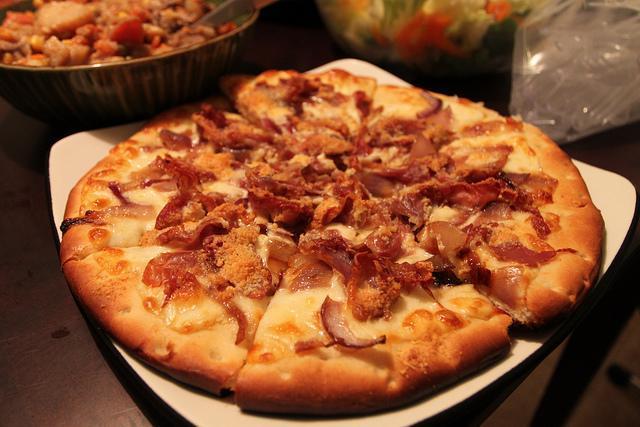How many slices are there?
Give a very brief answer. 6. How many dining tables are there?
Give a very brief answer. 1. How many kites are in the sky?
Give a very brief answer. 0. 